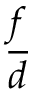Convert formula to latex. <formula><loc_0><loc_0><loc_500><loc_500>\frac { f } { d }</formula> 